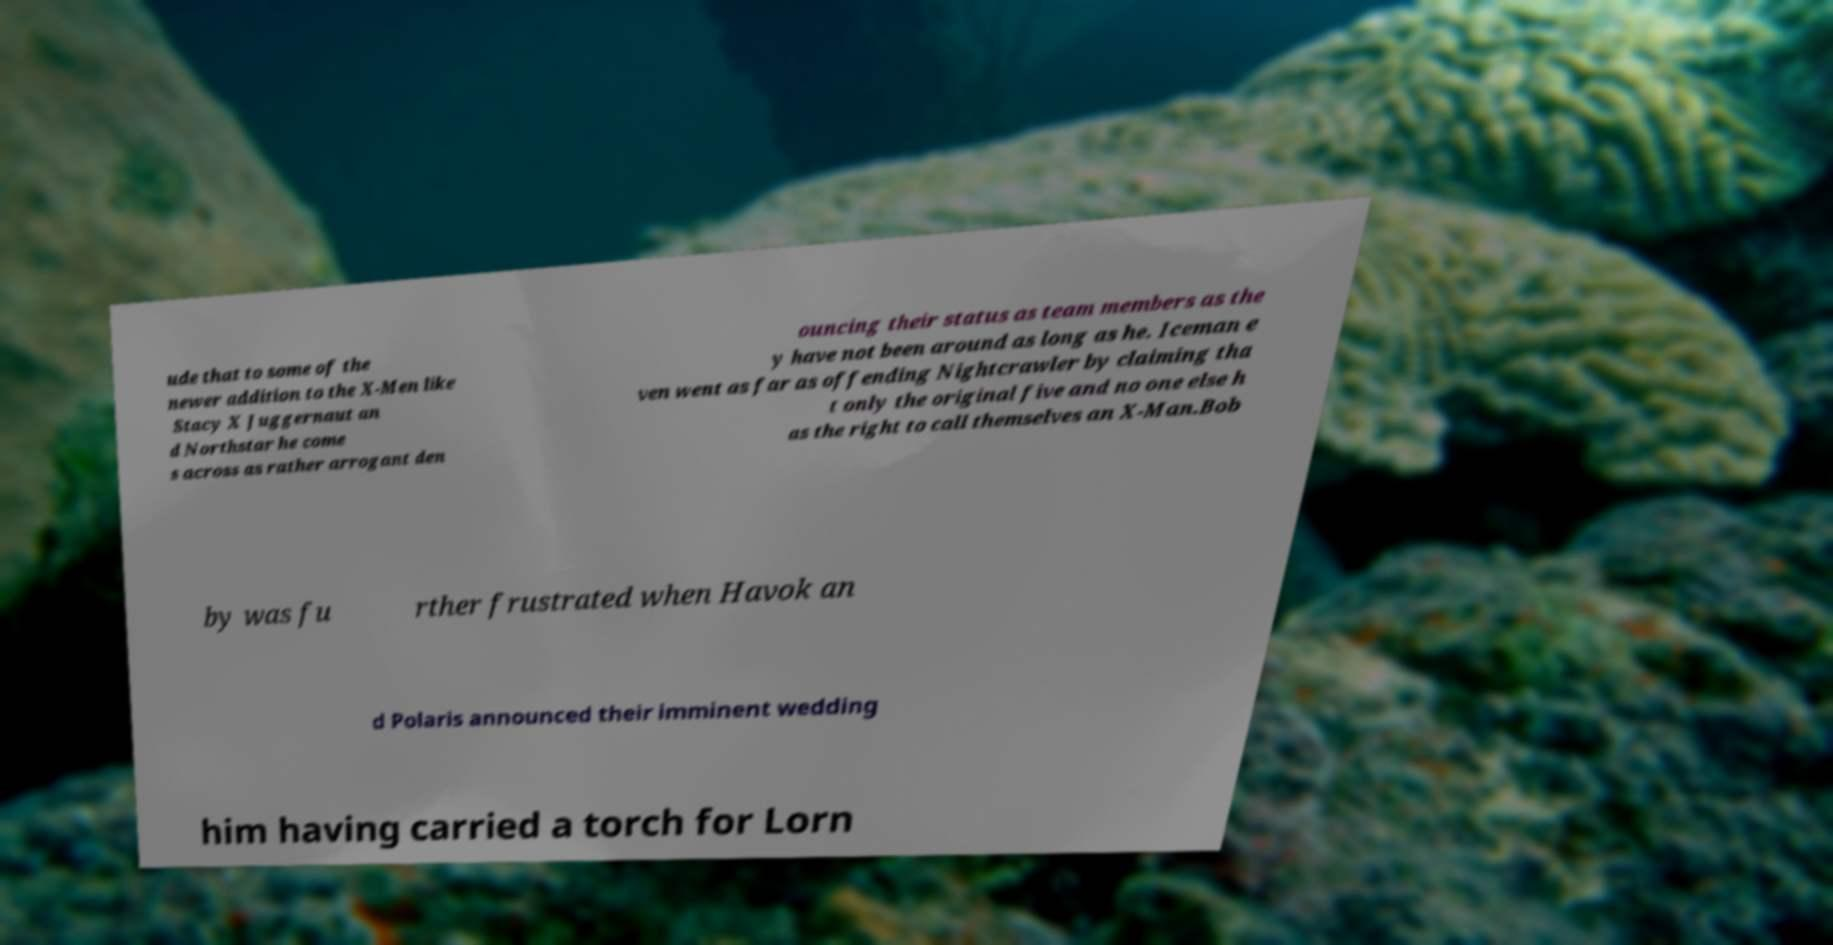Can you accurately transcribe the text from the provided image for me? ude that to some of the newer addition to the X-Men like Stacy X Juggernaut an d Northstar he come s across as rather arrogant den ouncing their status as team members as the y have not been around as long as he. Iceman e ven went as far as offending Nightcrawler by claiming tha t only the original five and no one else h as the right to call themselves an X-Man.Bob by was fu rther frustrated when Havok an d Polaris announced their imminent wedding him having carried a torch for Lorn 